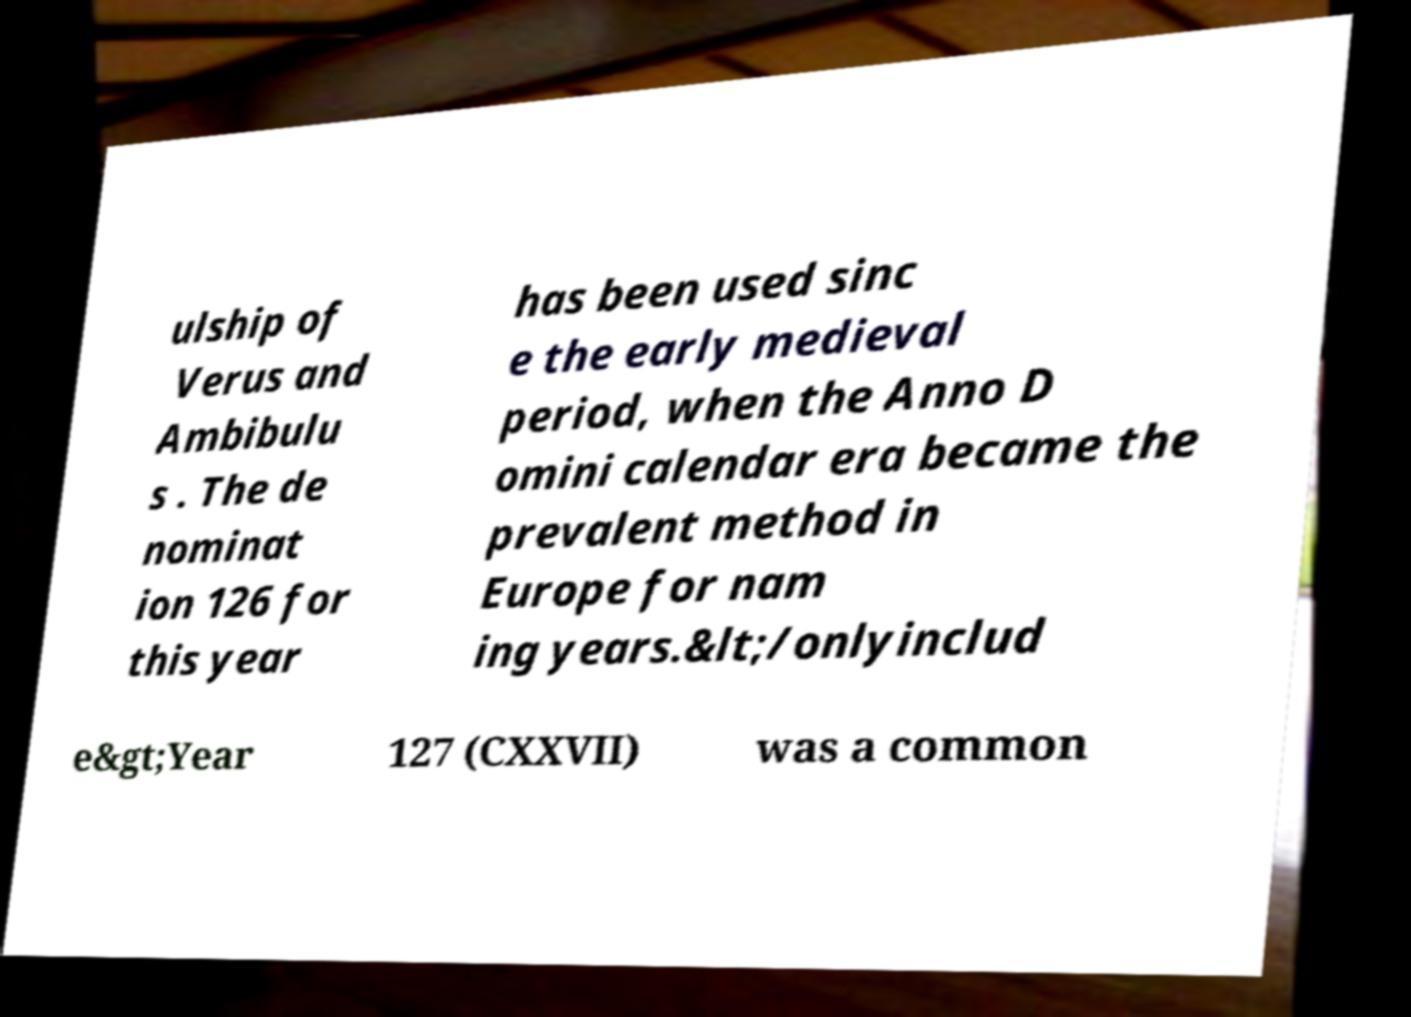What messages or text are displayed in this image? I need them in a readable, typed format. ulship of Verus and Ambibulu s . The de nominat ion 126 for this year has been used sinc e the early medieval period, when the Anno D omini calendar era became the prevalent method in Europe for nam ing years.&lt;/onlyinclud e&gt;Year 127 (CXXVII) was a common 